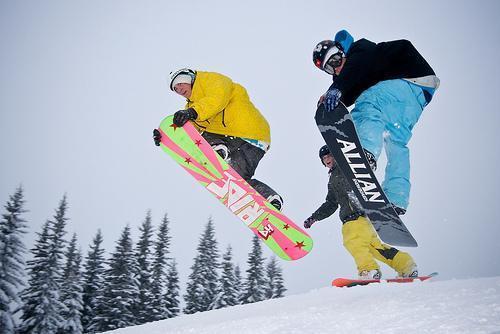How many people are there?
Give a very brief answer. 3. 